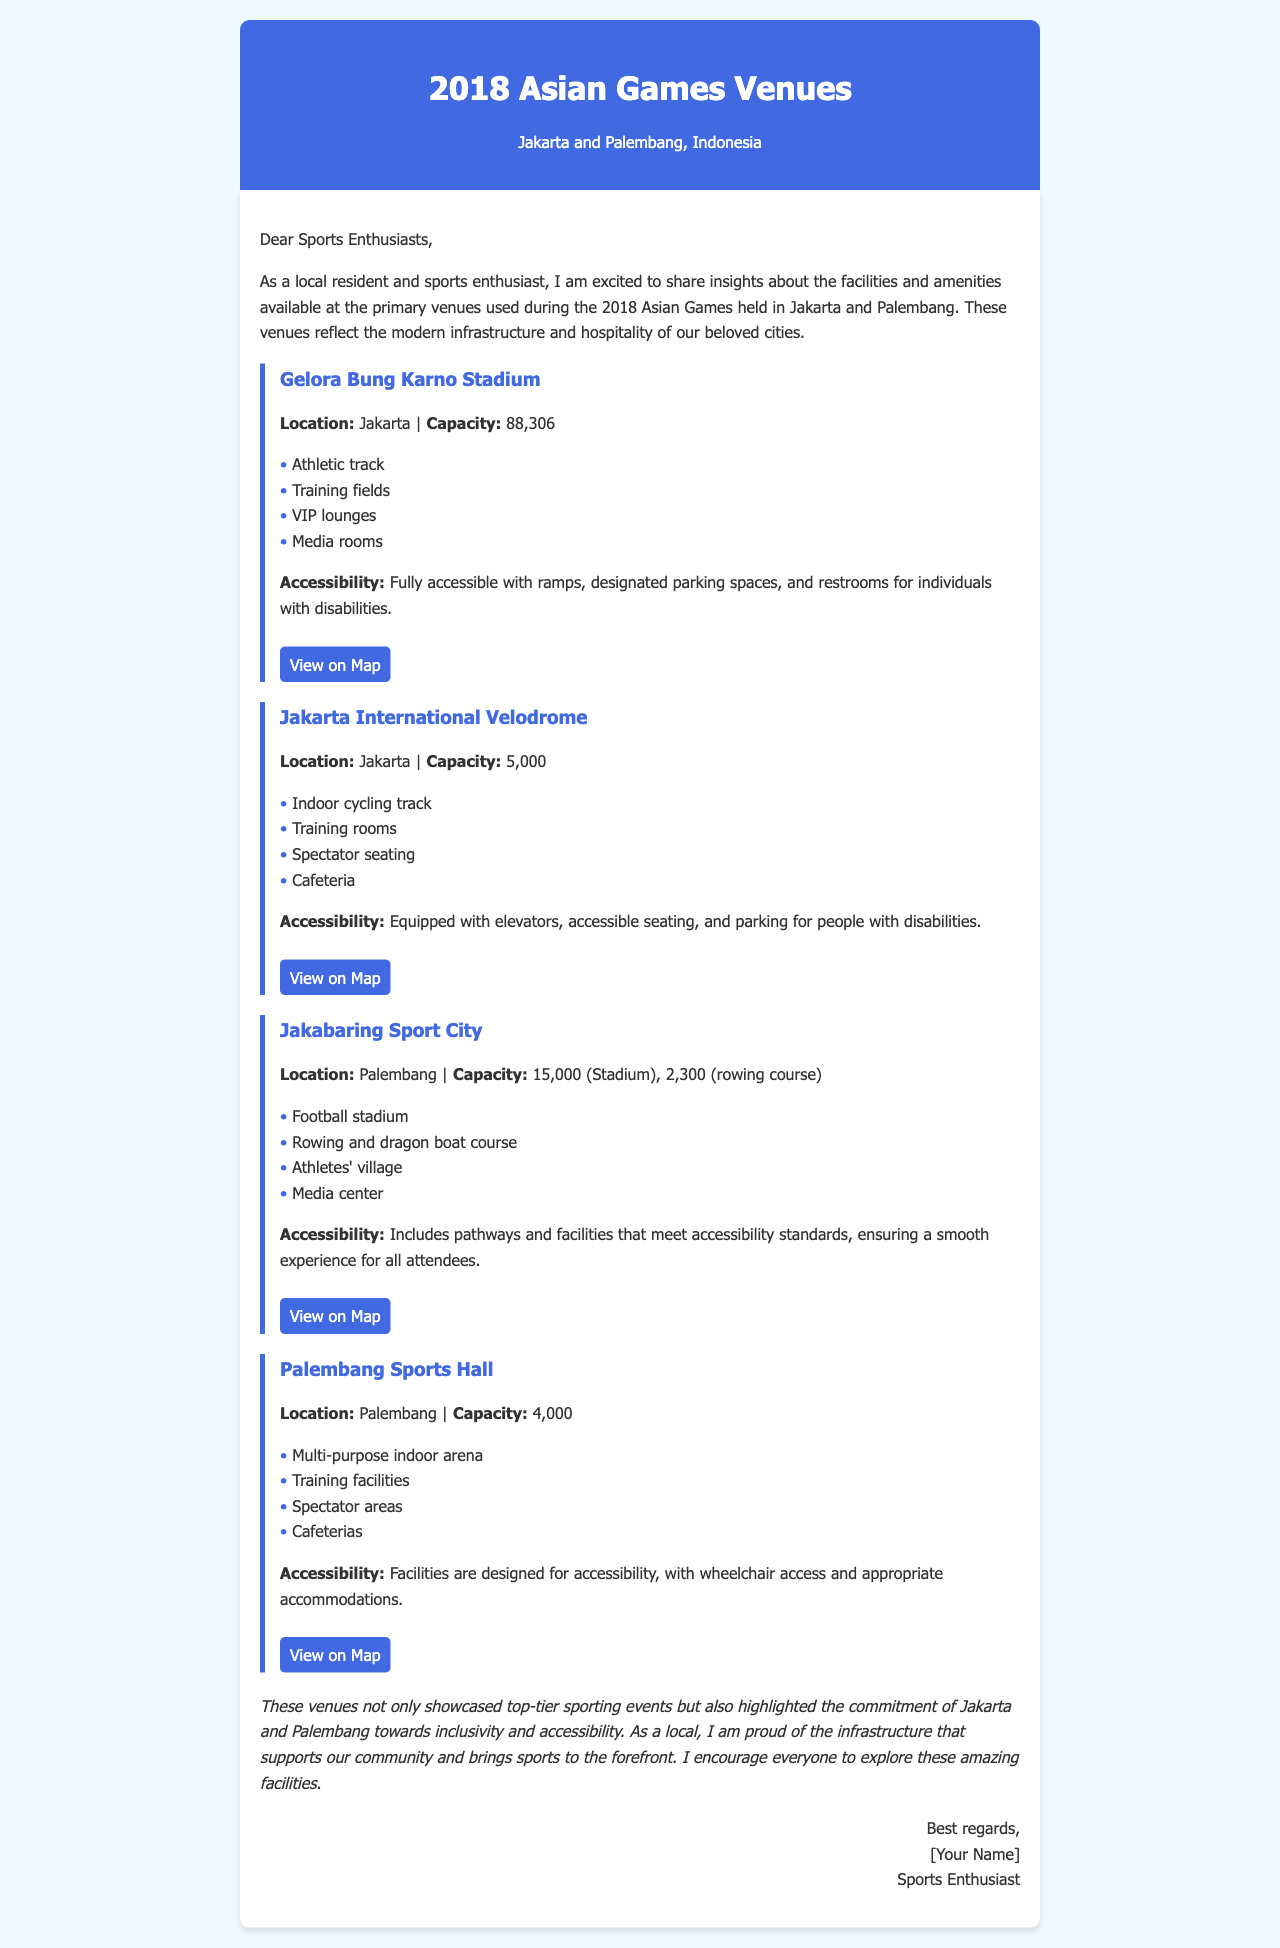What is the capacity of Gelora Bung Karno Stadium? The capacity of Gelora Bung Karno Stadium is mentioned as 88,306 in the document.
Answer: 88,306 What facilities are available at the Jakarta International Velodrome? The document lists facilities at the Jakarta International Velodrome such as an indoor cycling track, training rooms, spectator seating, and a cafeteria.
Answer: Indoor cycling track, training rooms, spectator seating, cafeteria How many venues are listed in the document? The document describes four venues used during the 2018 Asian Games, providing details for each.
Answer: Four What is the accessibility feature of Jakabaring Sport City? Jakabaring Sport City includes pathways and facilities that meet accessibility standards.
Answer: Pathways and facilities meet accessibility standards Where is Palembang Sports Hall located? The location of Palembang Sports Hall is provided as Palembang in the document.
Answer: Palembang How can one view the map of Gelora Bung Karno Stadium? There's a map link that allows viewing the location of Gelora Bung Karno Stadium on Google Maps.
Answer: View on Map What type of venue is the Palembang Sports Hall? The document describes Palembang Sports Hall as a multi-purpose indoor arena.
Answer: Multi-purpose indoor arena How many spectators can the Jakarta International Velodrome accommodate? The capacity of the Jakarta International Velodrome is stated as 5,000 in the document.
Answer: 5,000 